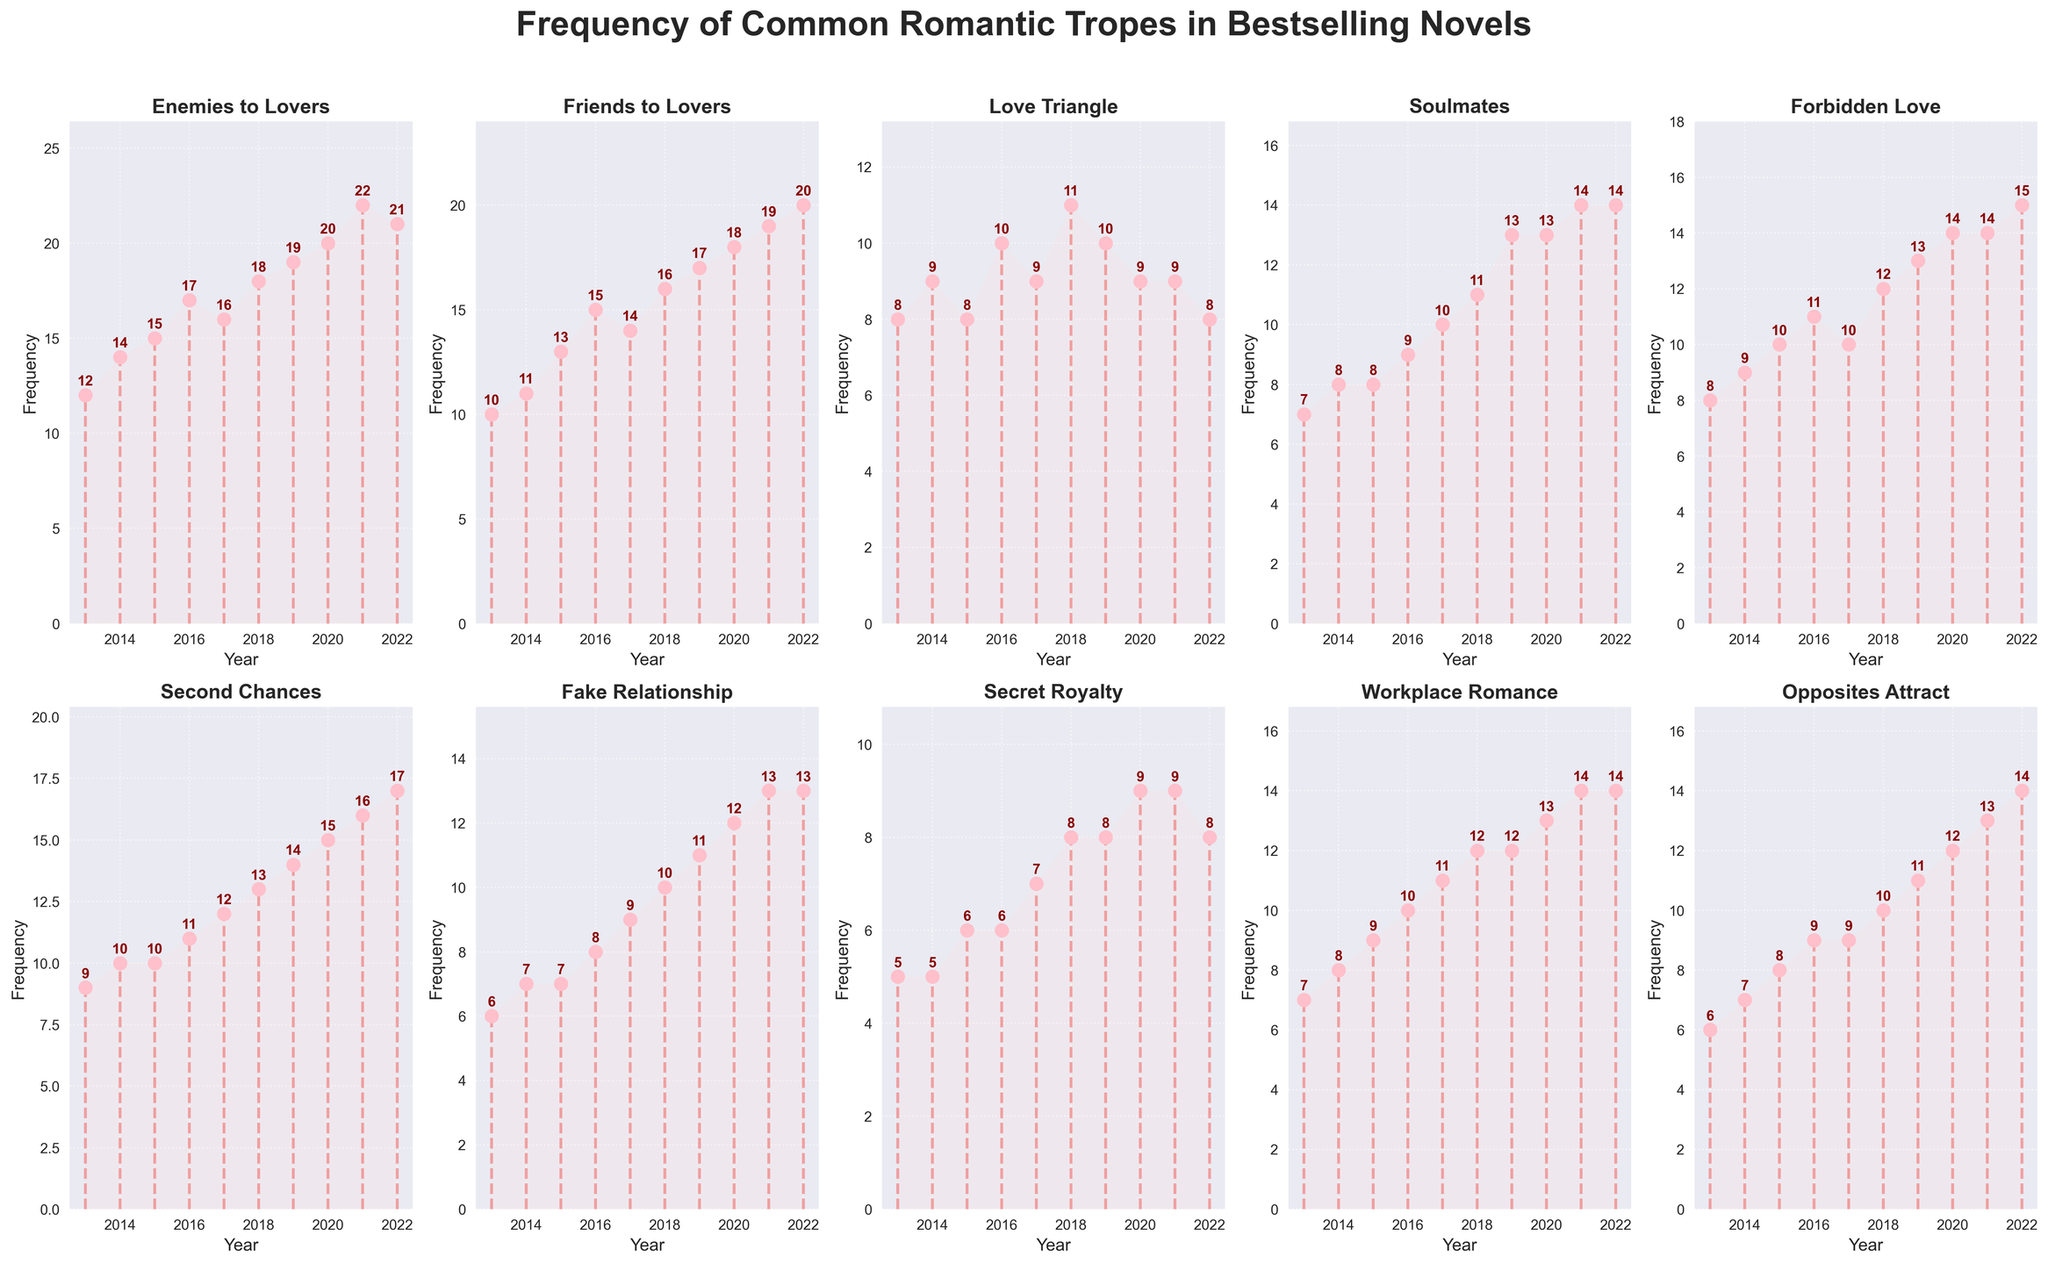What's the most frequent trope in 2022? To find the most frequent trope in 2022, look at the plot and identify the trope with the highest value in the year 2022.
Answer: Forbidden Love What's the least frequent trope in 2013? Look at the values for each trope in the year 2013 and find the smallest number.
Answer: Secret Royalty How did the frequency of 'Enemies to Lovers' change from 2013 to 2022? Compare the value of 'Enemies to Lovers' in 2013 (12) to the value in 2022 (21). Subtract the initial value from the final value to get the change. \( 21 - 12 = 9 \)
Answer: Increased by 9 Which trope has shown a consistent increase over the decade? Look for the trope whose values consistently increase from 2013 to 2022 without any drops.
Answer: Second Chances Which year had the highest frequency for 'Love Triangle'? Identify the peak value of 'Love Triangle' and note the corresponding year.
Answer: 2018 How many tropes had a frequency of 10 or more in 2015? Count the number of tropes where the value in 2015 is 10 or more.
Answer: 6 Which trope shows the steepest increase between any two consecutive years? Compare the changes year-over-year for each trope and find the largest increase.
Answer: Enemies to Lovers (from 2019 to 2020) Is there any trope with the same frequency in every year of the decade? Verify if there is any trope where the values are constant across all years.
Answer: No Compare the frequency of 'Fake Relationship' in 2013 and 'Soulmates' in 2013. Look at the values for 'Fake Relationship' and 'Soulmates' in 2013 and compare them.
Answer: Fake Relationship had a frequency of 6, while Soulmates had a frequency of 7 What's the average frequency of 'Workplace Romance' over the decade? Sum the values of 'Workplace Romance' from 2013 to 2022 and divide by the number of years (10). \( \frac{7 + 8 + 9 + 10 + 11 + 12 + 12 + 13 + 14 + 14}{10} = 11 \)
Answer: 11 